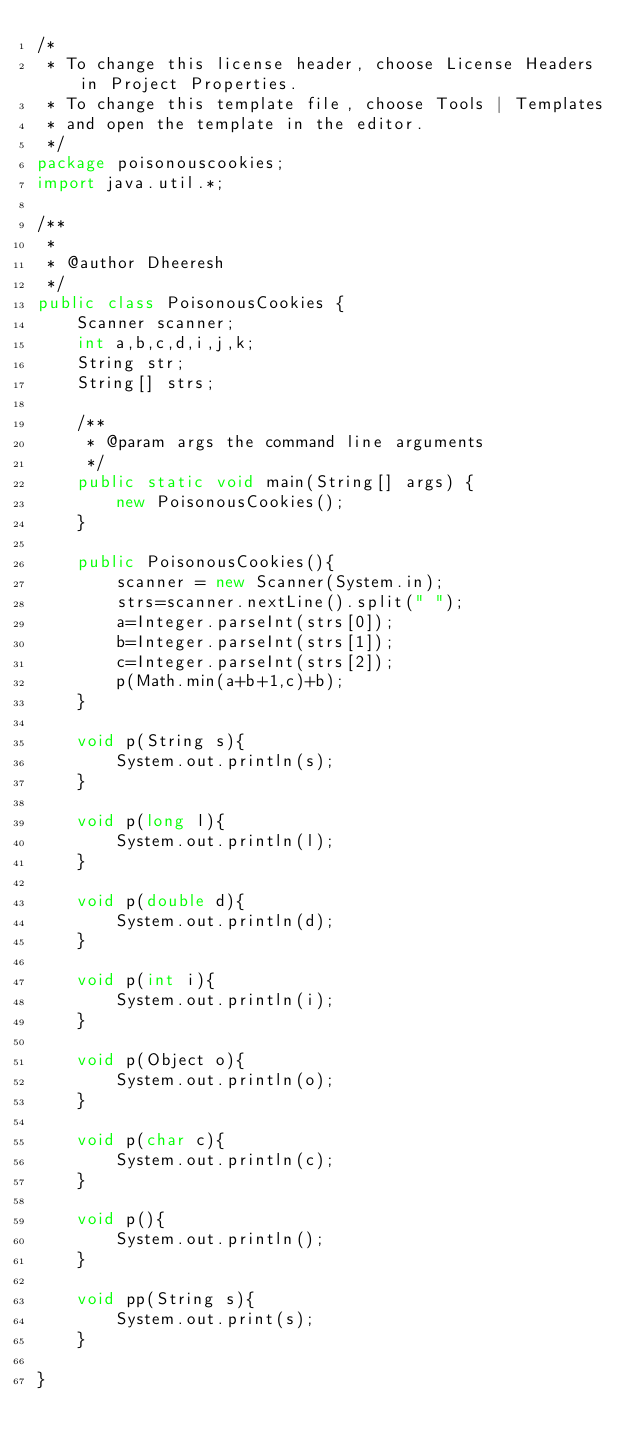Convert code to text. <code><loc_0><loc_0><loc_500><loc_500><_Java_>/*
 * To change this license header, choose License Headers in Project Properties.
 * To change this template file, choose Tools | Templates
 * and open the template in the editor.
 */
package poisonouscookies;
import java.util.*;

/**
 *
 * @author Dheeresh
 */
public class PoisonousCookies {
    Scanner scanner;
    int a,b,c,d,i,j,k;
    String str;
    String[] strs;

    /**
     * @param args the command line arguments
     */
    public static void main(String[] args) {
        new PoisonousCookies();
    }
    
    public PoisonousCookies(){
        scanner = new Scanner(System.in);
        strs=scanner.nextLine().split(" ");
        a=Integer.parseInt(strs[0]);
        b=Integer.parseInt(strs[1]);
        c=Integer.parseInt(strs[2]);
        p(Math.min(a+b+1,c)+b);
    }
    
    void p(String s){
        System.out.println(s);
    }
    
    void p(long l){
        System.out.println(l);
    }
    
    void p(double d){
        System.out.println(d);
    }
    
    void p(int i){
        System.out.println(i);
    }
    
    void p(Object o){
        System.out.println(o);
    }
    
    void p(char c){
        System.out.println(c);
    }
    
    void p(){
        System.out.println();
    }
    
    void pp(String s){
        System.out.print(s);
    }
    
}
</code> 